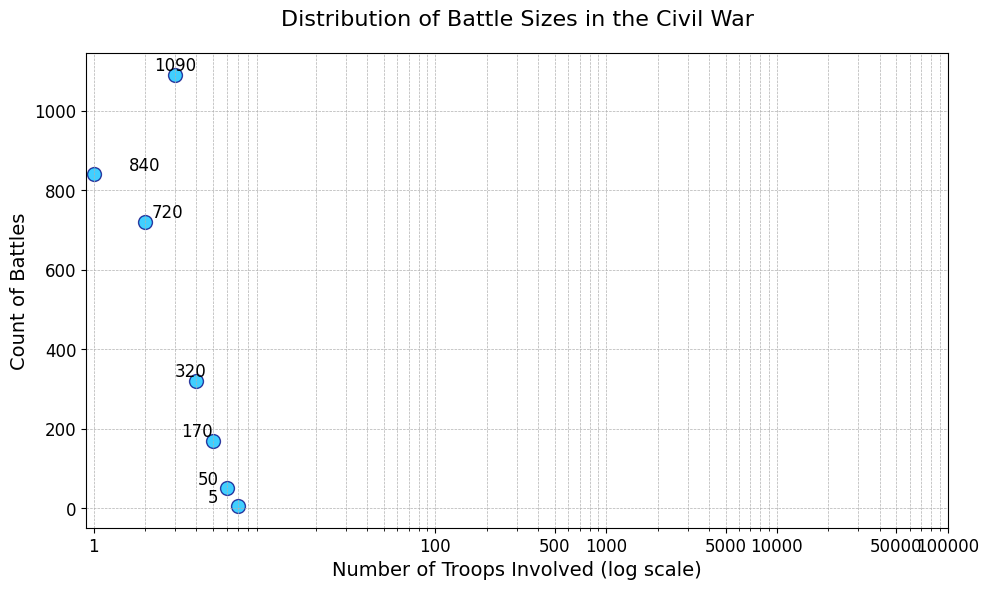What is the largest count of battles for a specific size category? The figure displays the count of battles for each battle size category. The category with the largest count is immediately visible. The highest point among the data points corresponds to the '1001-5000' category with a count of 1090.
Answer: 1090 Which troop size category has the smallest number of battles recorded? By observing the scatter points on the plot, the smallest count of battles is associated with the '100001-150000' category, which has only 5 battles.
Answer: 100001-150000 How does the count of battles in the '101-500' category compare to the '5001-10000' category? Comparing the two data points visually, the count of battles for '101-500' is 840 while for '5001-10000' it is 320. Consequently, '101-500' has significantly more battles compared to '5001-10000'.
Answer: '101-500' > '5001-10000' What is the total count of battles for the categories involving fewer than 1000 troops? The relevant categories are '1-100', '101-500', and '501-1000'. Adding their respective counts yields: 250 + 840 + 720 = 1810.
Answer: 1810 How do battles with troop sizes between 5001 and 50000 compare in terms of counts? To compare, we sum the counts for categories '5001-10000' (320) and '10001-50000' (170). Summing these gives 320 + 170 = 490.
Answer: 490 What percentage of battles involved more than 50000 troops? First, we identify the counts for the categories '50001-100000' (50) and '100001-150000' (5), summing up to 55. Total battles are 250 + 840 + 720 + 1090 + 320 + 170 + 50 + 5 = 3445. The percentage calculation is (55/3445) * 100 ≈ 1.6%.
Answer: About 1.6% What is the most common battle size range based on the figure? Observing the plot shows that the '1001-5000' category has the highest count of battles which is 1090, making it the most common battle size range.
Answer: '1001-5000' Between which troop sizes does the steepest drop in the count of battles occur? Visually identifying the steepest drop by looking at the gaps between points, the largest drop in the count appears between '1001-5000' (1090) and '5001-10000' (320).
Answer: '1001-5000' to '5001-10000' If you combine the counts for the '5001-10000' and '10001-50000' categories, how does their total compare to the count of the '1001-5000' category? Adding counts for '5001-10000' (320) and '10001-50000' (170) gives 490. The count of '1001-5000' is 1090, which is significantly higher.
Answer: 1090 > 490 What is the ratio of battles with '1-100' troops to those with '50001-100000' troops? The counts for the categories '1-100' and '50001-100000' are 250 and 50 respectively. The ratio is 250:50, which simplifies to 5:1.
Answer: 5:1 